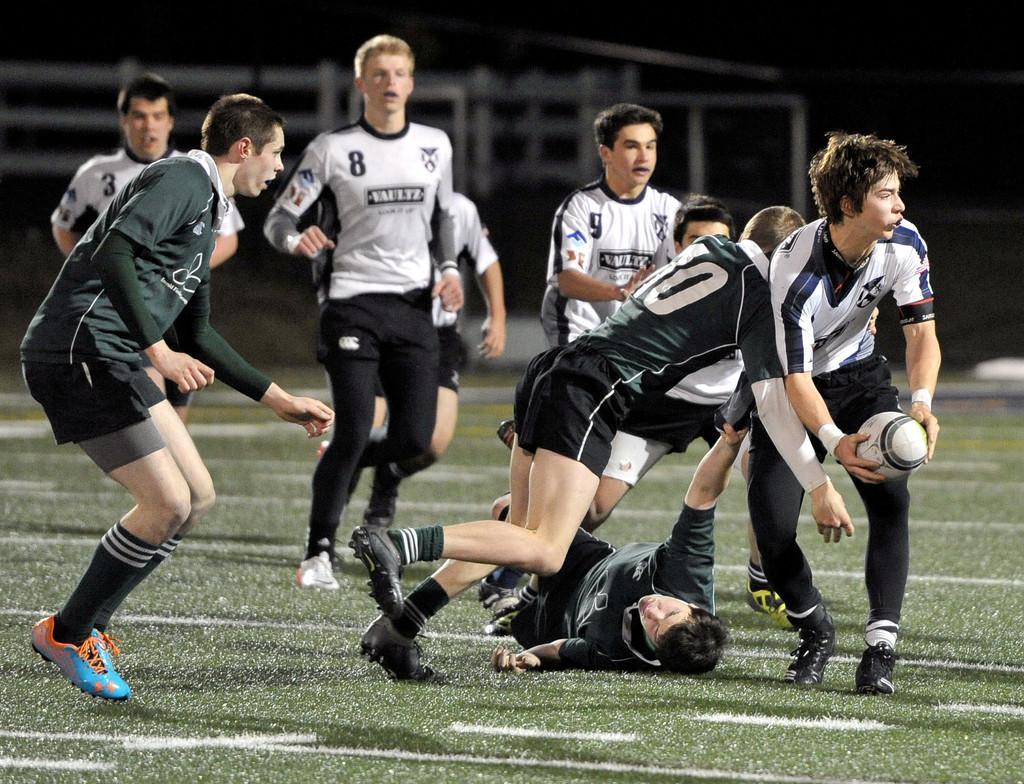Can you describe this image briefly? In the center of the image there are people playing. At the bottom of the image there is grass. 